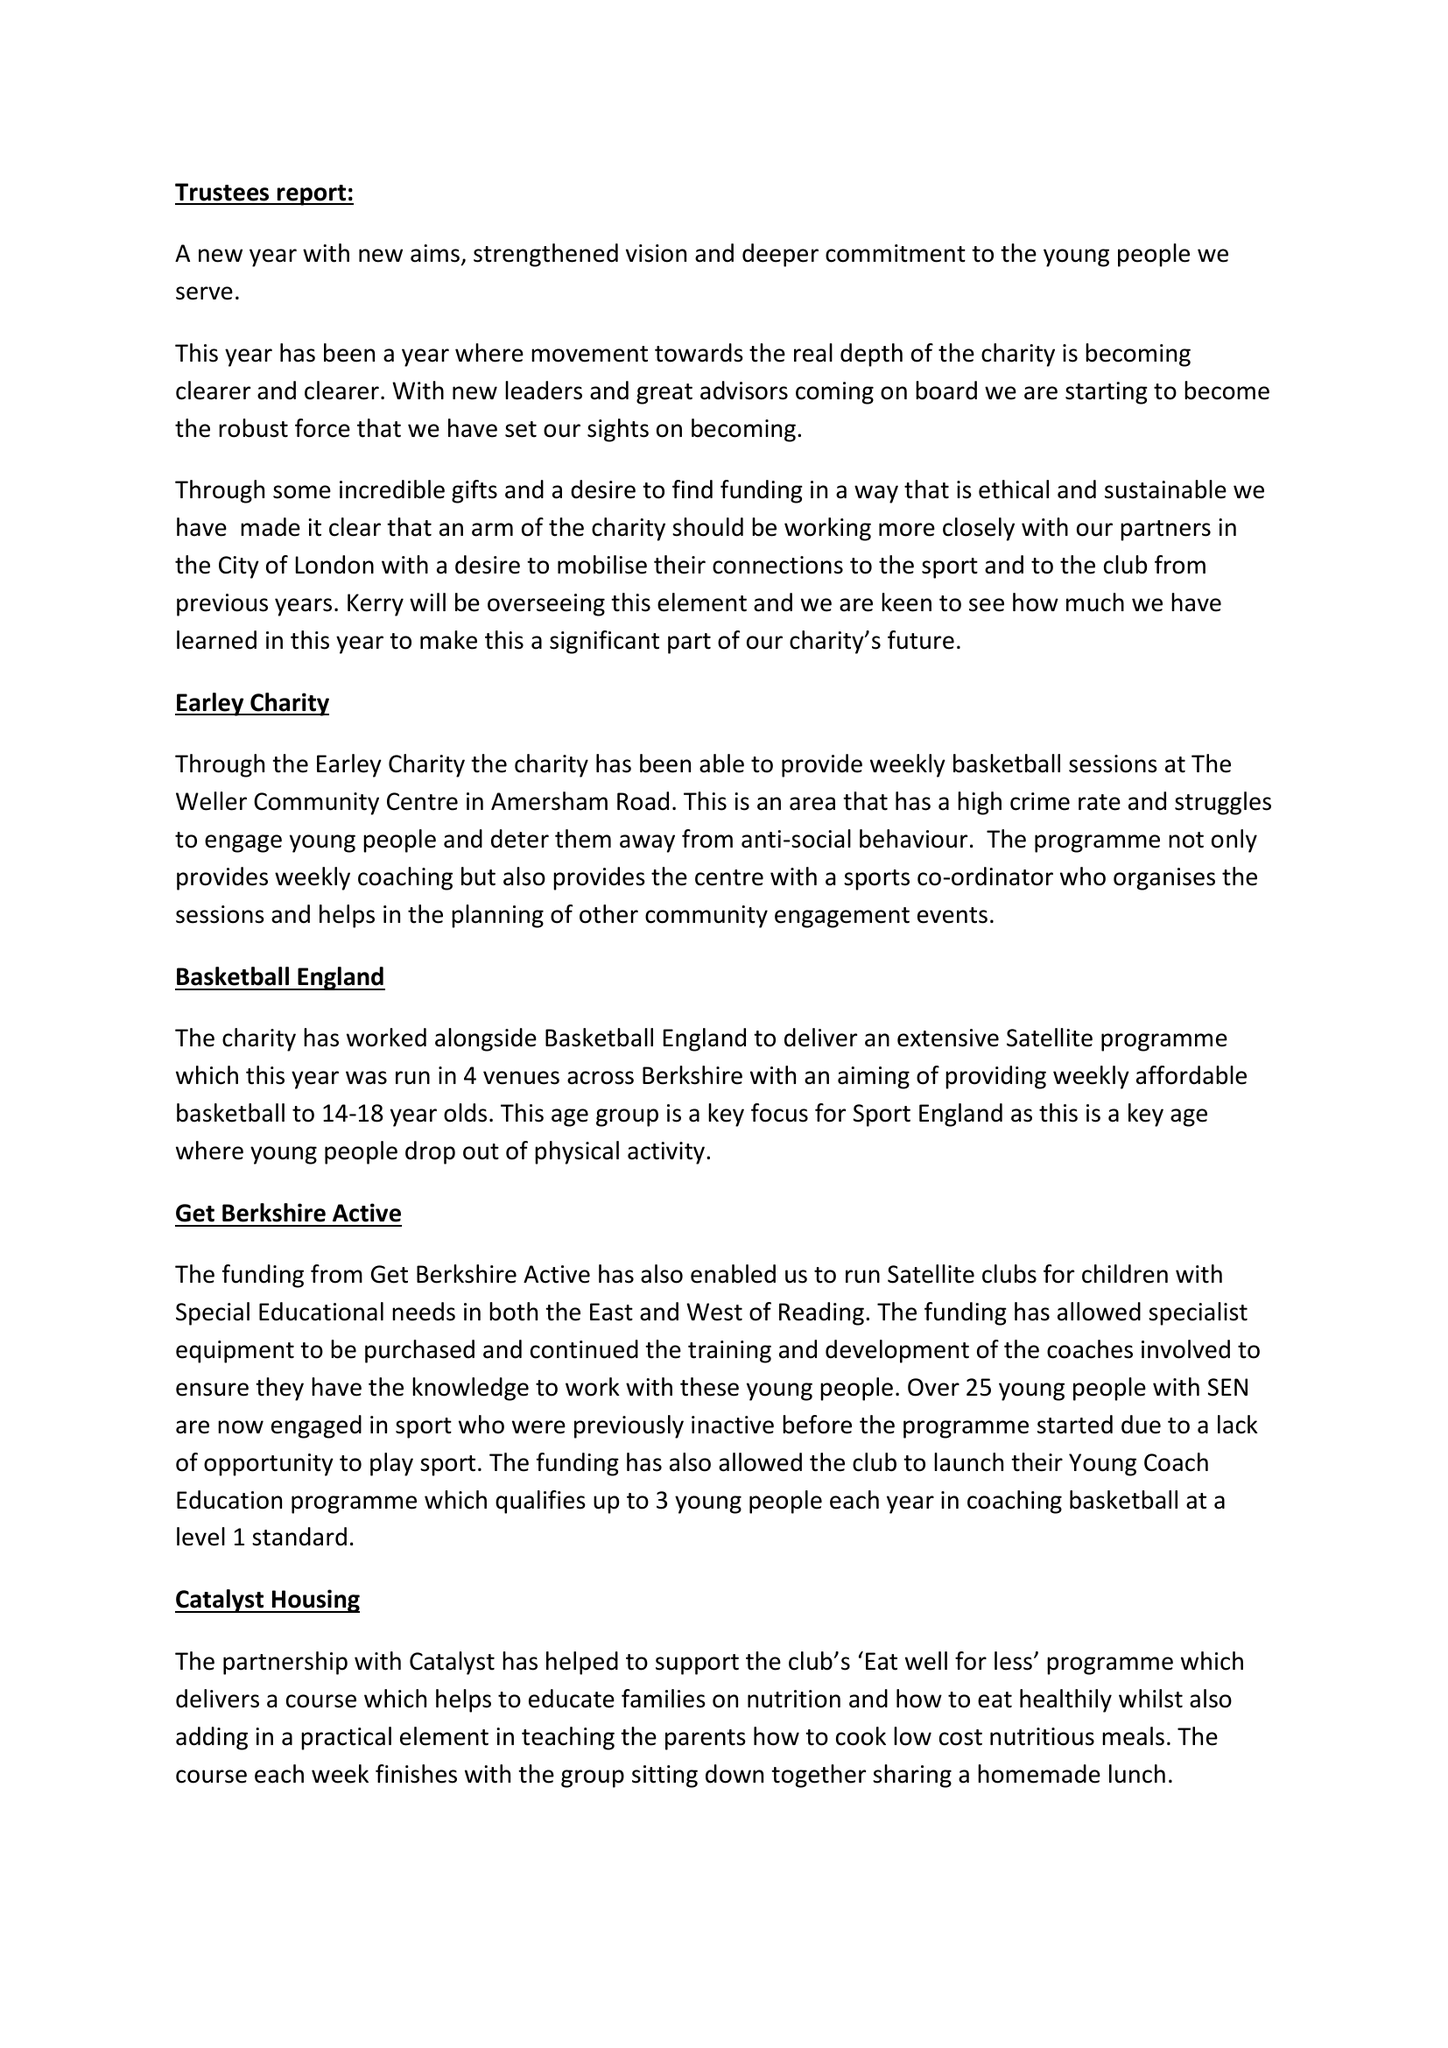What is the value for the address__postcode?
Answer the question using a single word or phrase. RG6 7JX 